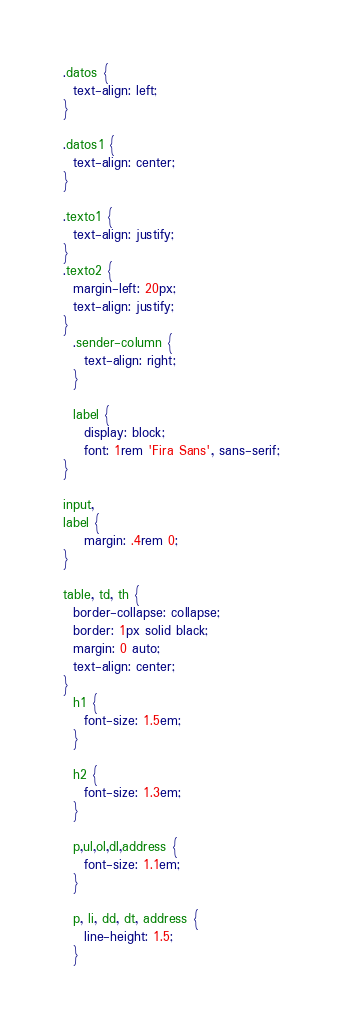Convert code to text. <code><loc_0><loc_0><loc_500><loc_500><_CSS_>.datos {
  text-align: left;
}

.datos1 {
  text-align: center;
}

.texto1 {
  text-align: justify;
}
.texto2 {
  margin-left: 20px;
  text-align: justify;
}
  .sender-column {
    text-align: right;
  }
  
  label {
    display: block;
    font: 1rem 'Fira Sans', sans-serif;
}

input,
label {
    margin: .4rem 0;
}

table, td, th {
  border-collapse: collapse;
  border: 1px solid black;
  margin: 0 auto;
  text-align: center;
}
  h1 {
    font-size: 1.5em;
  }
  
  h2 {
    font-size: 1.3em;
  }
  
  p,ul,ol,dl,address {
    font-size: 1.1em;
  }
  
  p, li, dd, dt, address {
    line-height: 1.5;
  }</code> 